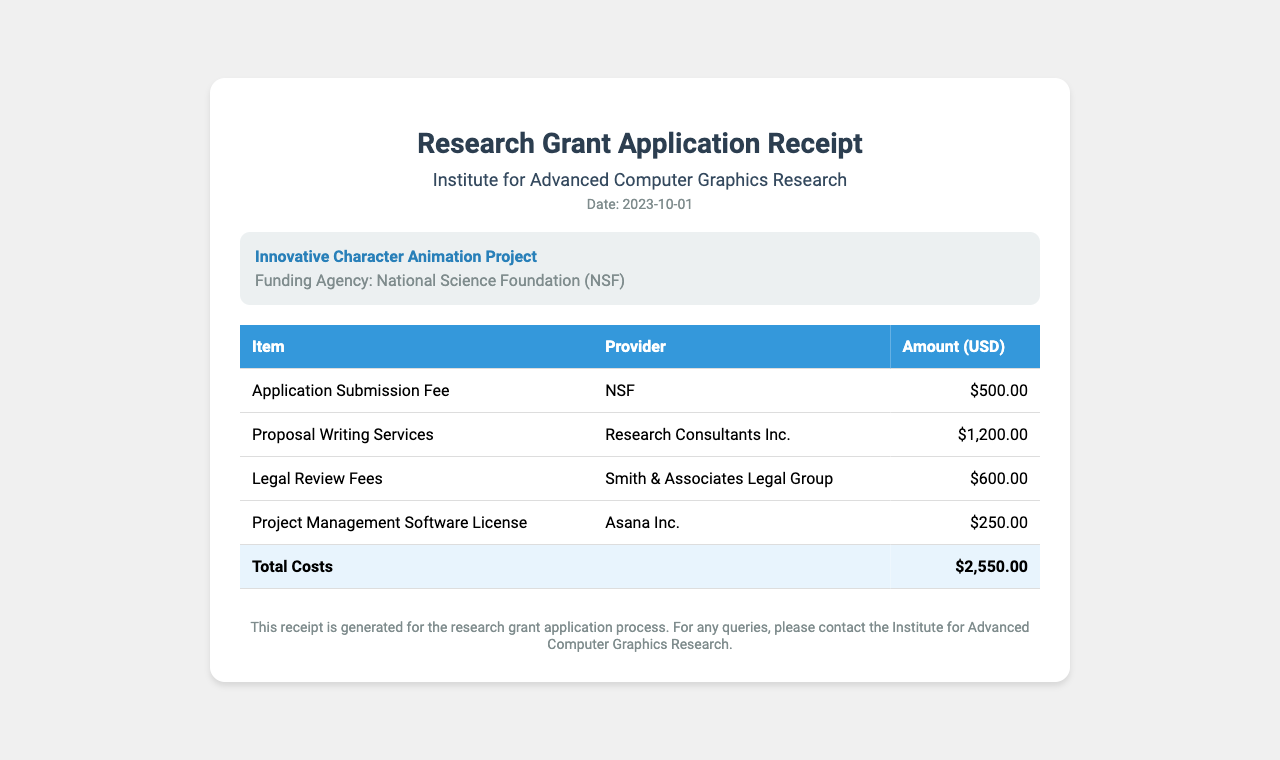What is the date of the receipt? The date of the receipt is stated directly in the document.
Answer: 2023-10-01 Who is the funding agency? The funding agency is mentioned in the project information section of the receipt.
Answer: National Science Foundation (NSF) What is the amount for the Application Submission Fee? The amount for the Application Submission Fee is listed in the table of items.
Answer: $500.00 What is the total amount of costs? The total amount of costs is displayed at the bottom of the table summarizing all expenses.
Answer: $2,550.00 Which organization is providing proposal writing services? The provider for proposal writing services is given alongside the associated cost in the document.
Answer: Research Consultants Inc How many line items are listed in the receipt? The number of line items can be counted in the table of the document excluding the total row.
Answer: 4 What type of document is this? The type of document is indicated in the header of the receipt.
Answer: Research Grant Application Receipt What is the purpose of this receipt? The purpose is implied in the footer section of the document, summarizing its utility.
Answer: Research grant application process 